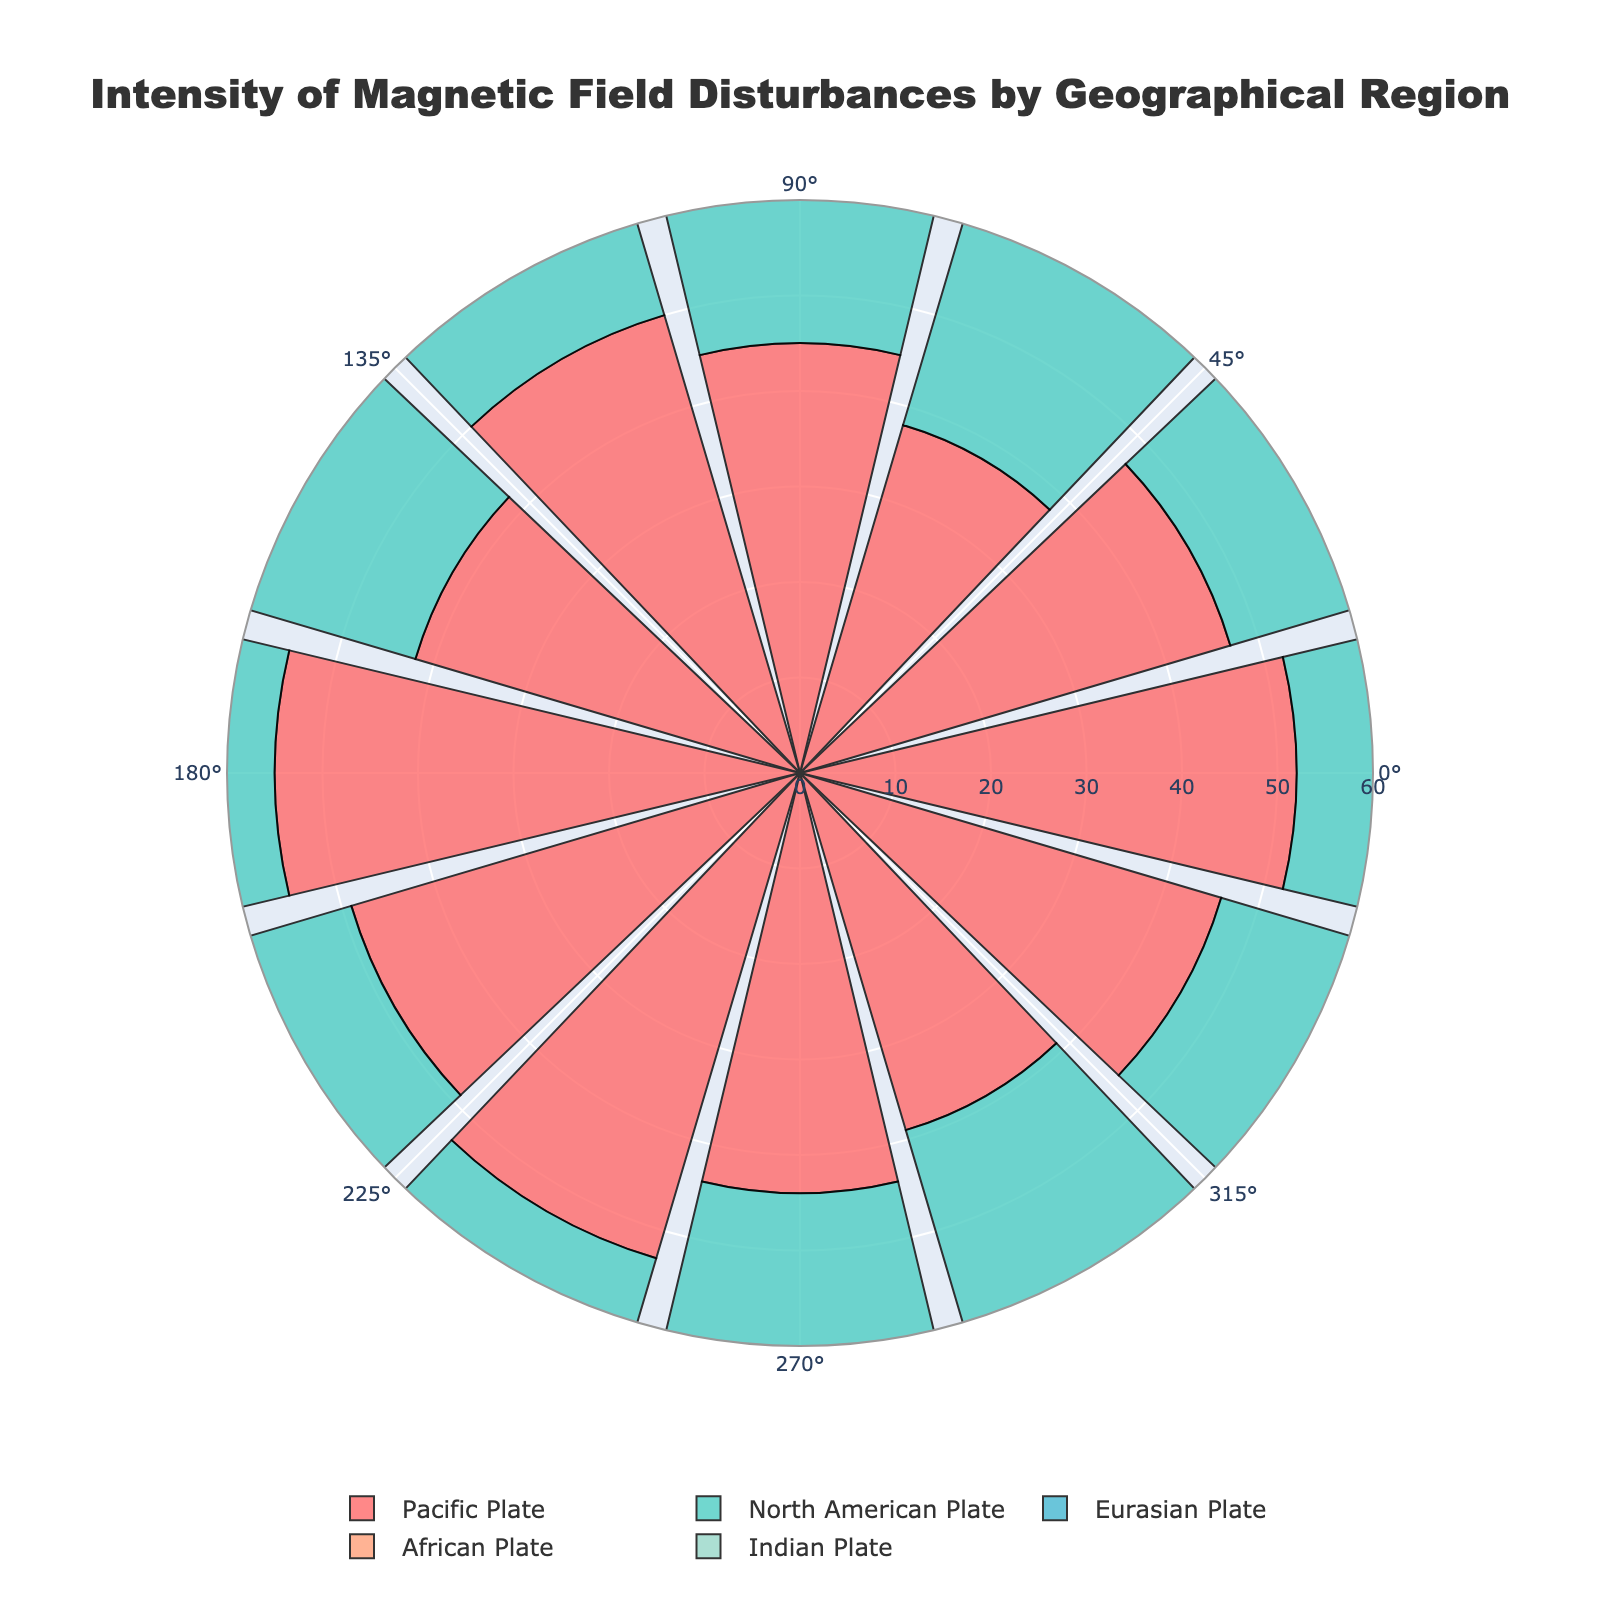How many geographical regions are displayed in the rose chart? To determine the number of geographical regions, count the distinct color sections or legend entries representing different regions.
Answer: 5 Which region has the highest intensity value? By inspecting the radial lengths in the plot, the region with the largest bar signifies the highest intensity value. The Pacific Plate has the longest bar, indicative of an intensity of 55 at a 180-degree angle.
Answer: Pacific Plate What is the average intensity of the North American Plate? Sum the intensity values for the North American Plate and divide by the number of measurements. Calculation: (43 + 48 + 40 + 35 + 47 + 50 + 36 + 44 + 41 + 39 + 46 + 45) / 12
Answer: 43.25 At which measurement angle does the Eurasian Plate show the lowest intensity? Look for the shortest bar within the Eurasian Plate's dataset. The shortest bar occurs at a 90-degree angle with an intensity of 43.
Answer: 90-degree Compare the intensity of magnetic field disturbances at 120 degrees for the Pacific Plate and the Indian Plate. Which one is higher? Inspect the bars at a 120-degree angle for both regions. The Pacific Plate has an intensity of 50, whereas the Indian Plate has an intensity of 48.
Answer: Pacific Plate Which region shows the highest variability in intensity? Determine variability by visually inspecting the spread of bar lengths for each region. The Pacific Plate shows a noticeable range from 38 to 55, indicating the highest variability.
Answer: Pacific Plate Calculate the difference in intensity for the African Plate between 240 degrees and 300 degrees. Subtract the intensity value at 300 degrees from the value at 240 degrees. Calculation: 42 - 41
Answer: 1 Which region has the most consistent intensity values across different measurement angles? Consistency can be identified by the uniformity in bar lengths. The Eurasian Plate’s bars are nearly equal in length, suggesting the most consistent intensity values.
Answer: Eurasian Plate What are the intensity ranges for the Indian Plate? Identify the minimum and maximum intensity values for the Indian Plate from the chart. The minimum is 39 at a 90-degree angle, and the maximum is 50 at a 150-degree angle.
Answer: 39 to 50 